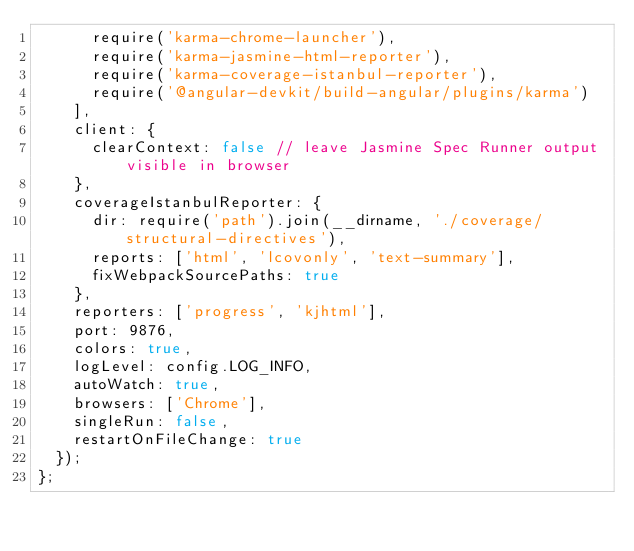<code> <loc_0><loc_0><loc_500><loc_500><_JavaScript_>      require('karma-chrome-launcher'),
      require('karma-jasmine-html-reporter'),
      require('karma-coverage-istanbul-reporter'),
      require('@angular-devkit/build-angular/plugins/karma')
    ],
    client: {
      clearContext: false // leave Jasmine Spec Runner output visible in browser
    },
    coverageIstanbulReporter: {
      dir: require('path').join(__dirname, './coverage/structural-directives'),
      reports: ['html', 'lcovonly', 'text-summary'],
      fixWebpackSourcePaths: true
    },
    reporters: ['progress', 'kjhtml'],
    port: 9876,
    colors: true,
    logLevel: config.LOG_INFO,
    autoWatch: true,
    browsers: ['Chrome'],
    singleRun: false,
    restartOnFileChange: true
  });
};
</code> 